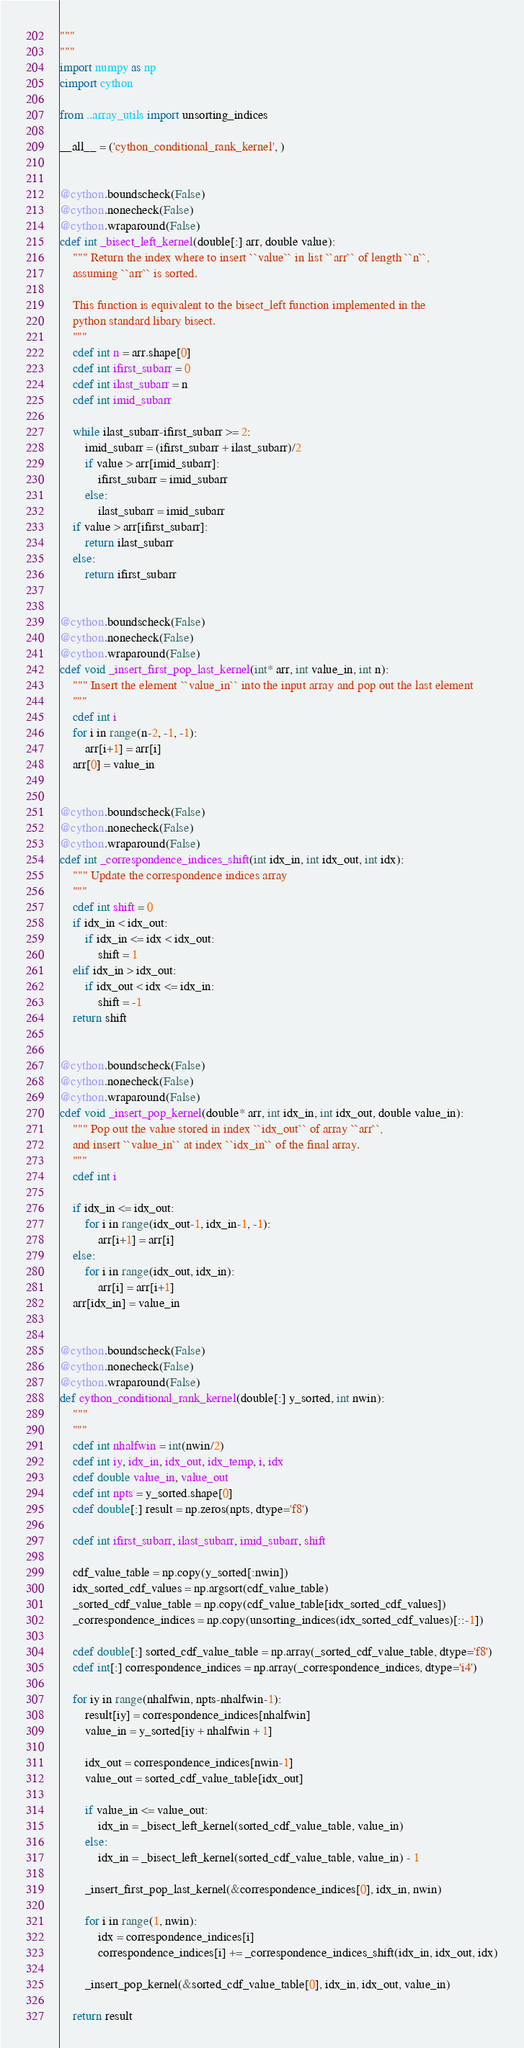Convert code to text. <code><loc_0><loc_0><loc_500><loc_500><_Cython_>"""
"""
import numpy as np
cimport cython

from ..array_utils import unsorting_indices

__all__ = ('cython_conditional_rank_kernel', )


@cython.boundscheck(False)
@cython.nonecheck(False)
@cython.wraparound(False)
cdef int _bisect_left_kernel(double[:] arr, double value):
    """ Return the index where to insert ``value`` in list ``arr`` of length ``n``,
    assuming ``arr`` is sorted.

    This function is equivalent to the bisect_left function implemented in the
    python standard libary bisect.
    """
    cdef int n = arr.shape[0]
    cdef int ifirst_subarr = 0
    cdef int ilast_subarr = n
    cdef int imid_subarr

    while ilast_subarr-ifirst_subarr >= 2:
        imid_subarr = (ifirst_subarr + ilast_subarr)/2
        if value > arr[imid_subarr]:
            ifirst_subarr = imid_subarr
        else:
            ilast_subarr = imid_subarr
    if value > arr[ifirst_subarr]:
        return ilast_subarr
    else:
        return ifirst_subarr


@cython.boundscheck(False)
@cython.nonecheck(False)
@cython.wraparound(False)
cdef void _insert_first_pop_last_kernel(int* arr, int value_in, int n):
    """ Insert the element ``value_in`` into the input array and pop out the last element
    """
    cdef int i
    for i in range(n-2, -1, -1):
        arr[i+1] = arr[i]
    arr[0] = value_in


@cython.boundscheck(False)
@cython.nonecheck(False)
@cython.wraparound(False)
cdef int _correspondence_indices_shift(int idx_in, int idx_out, int idx):
    """ Update the correspondence indices array
    """
    cdef int shift = 0
    if idx_in < idx_out:
        if idx_in <= idx < idx_out:
            shift = 1
    elif idx_in > idx_out:
        if idx_out < idx <= idx_in:
            shift = -1
    return shift


@cython.boundscheck(False)
@cython.nonecheck(False)
@cython.wraparound(False)
cdef void _insert_pop_kernel(double* arr, int idx_in, int idx_out, double value_in):
    """ Pop out the value stored in index ``idx_out`` of array ``arr``,
    and insert ``value_in`` at index ``idx_in`` of the final array.
    """
    cdef int i

    if idx_in <= idx_out:
        for i in range(idx_out-1, idx_in-1, -1):
            arr[i+1] = arr[i]
    else:
        for i in range(idx_out, idx_in):
            arr[i] = arr[i+1]
    arr[idx_in] = value_in


@cython.boundscheck(False)
@cython.nonecheck(False)
@cython.wraparound(False)
def cython_conditional_rank_kernel(double[:] y_sorted, int nwin):
    """
    """
    cdef int nhalfwin = int(nwin/2)
    cdef int iy, idx_in, idx_out, idx_temp, i, idx
    cdef double value_in, value_out
    cdef int npts = y_sorted.shape[0]
    cdef double[:] result = np.zeros(npts, dtype='f8')

    cdef int ifirst_subarr, ilast_subarr, imid_subarr, shift

    cdf_value_table = np.copy(y_sorted[:nwin])
    idx_sorted_cdf_values = np.argsort(cdf_value_table)
    _sorted_cdf_value_table = np.copy(cdf_value_table[idx_sorted_cdf_values])
    _correspondence_indices = np.copy(unsorting_indices(idx_sorted_cdf_values)[::-1])

    cdef double[:] sorted_cdf_value_table = np.array(_sorted_cdf_value_table, dtype='f8')
    cdef int[:] correspondence_indices = np.array(_correspondence_indices, dtype='i4')

    for iy in range(nhalfwin, npts-nhalfwin-1):
        result[iy] = correspondence_indices[nhalfwin]
        value_in = y_sorted[iy + nhalfwin + 1]

        idx_out = correspondence_indices[nwin-1]
        value_out = sorted_cdf_value_table[idx_out]

        if value_in <= value_out:
            idx_in = _bisect_left_kernel(sorted_cdf_value_table, value_in)
        else:
            idx_in = _bisect_left_kernel(sorted_cdf_value_table, value_in) - 1

        _insert_first_pop_last_kernel(&correspondence_indices[0], idx_in, nwin)

        for i in range(1, nwin):
            idx = correspondence_indices[i]
            correspondence_indices[i] += _correspondence_indices_shift(idx_in, idx_out, idx)

        _insert_pop_kernel(&sorted_cdf_value_table[0], idx_in, idx_out, value_in)

    return result
</code> 